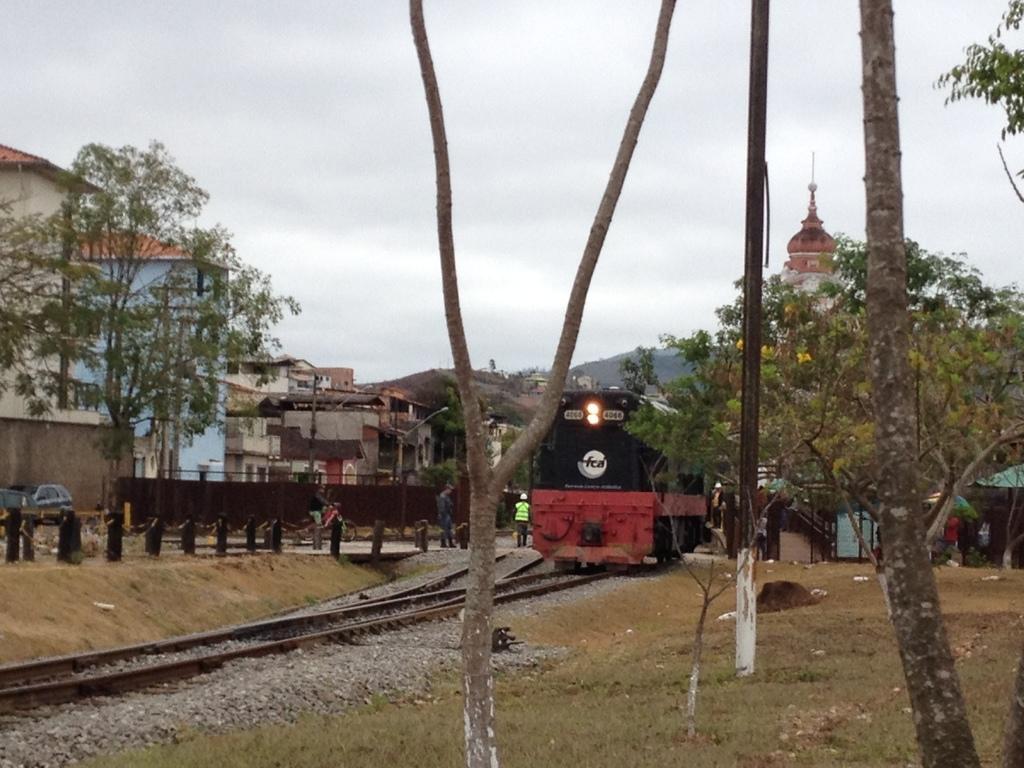Can you describe this image briefly? In this image we can see a train on a railway track. There is a grassy land in the image. There are many house in the image. A person is riding a motorbike and two more people are standing. 